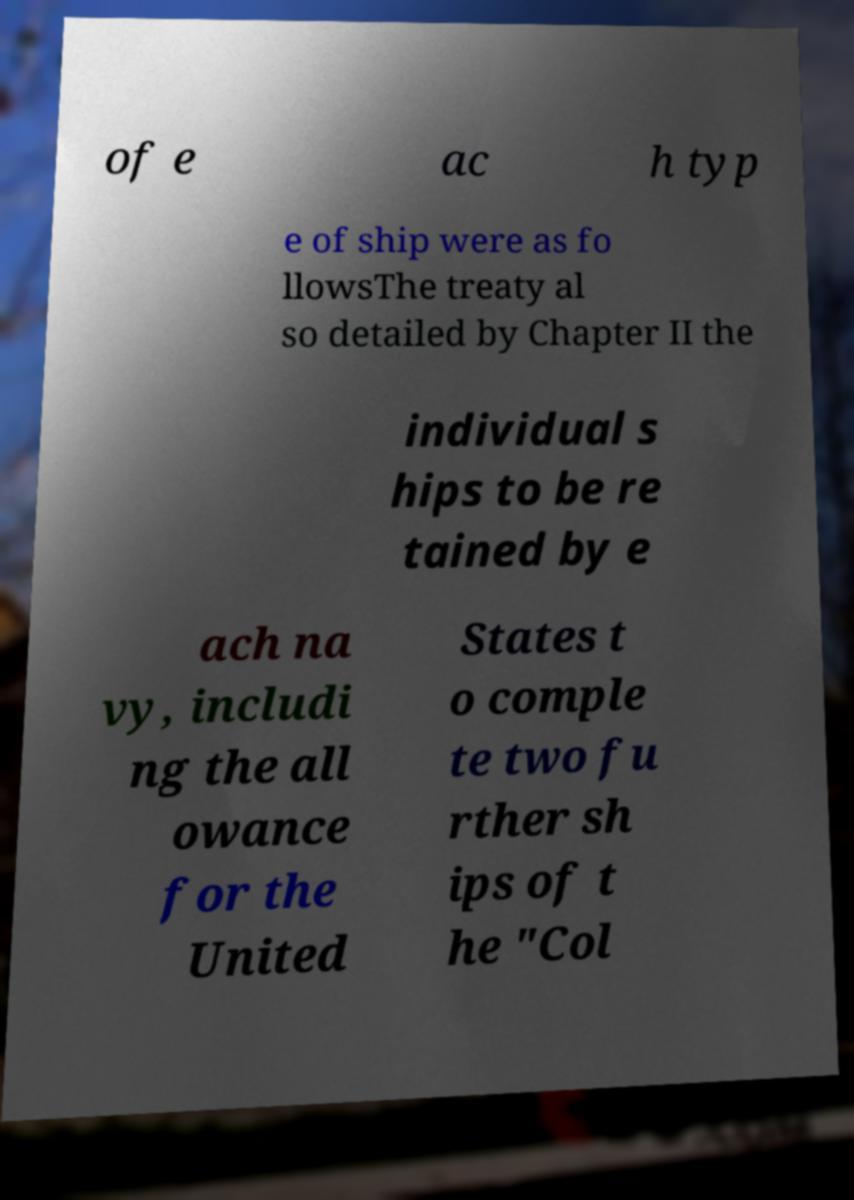Could you extract and type out the text from this image? of e ac h typ e of ship were as fo llowsThe treaty al so detailed by Chapter II the individual s hips to be re tained by e ach na vy, includi ng the all owance for the United States t o comple te two fu rther sh ips of t he "Col 